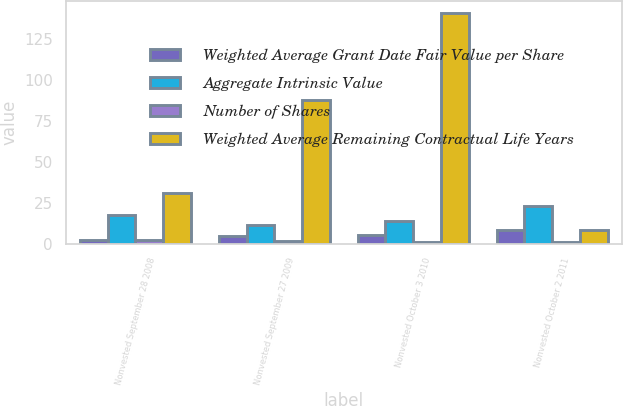Convert chart. <chart><loc_0><loc_0><loc_500><loc_500><stacked_bar_chart><ecel><fcel>Nonvested September 28 2008<fcel>Nonvested September 27 2009<fcel>Nonvested October 3 2010<fcel>Nonvested October 2 2011<nl><fcel>Weighted Average Grant Date Fair Value per Share<fcel>2<fcel>4.4<fcel>5.4<fcel>8.3<nl><fcel>Aggregate Intrinsic Value<fcel>17.36<fcel>11.55<fcel>13.55<fcel>23.11<nl><fcel>Number of Shares<fcel>2.5<fcel>1.6<fcel>1.1<fcel>0.8<nl><fcel>Weighted Average Remaining Contractual Life Years<fcel>31<fcel>88<fcel>141<fcel>8.3<nl></chart> 